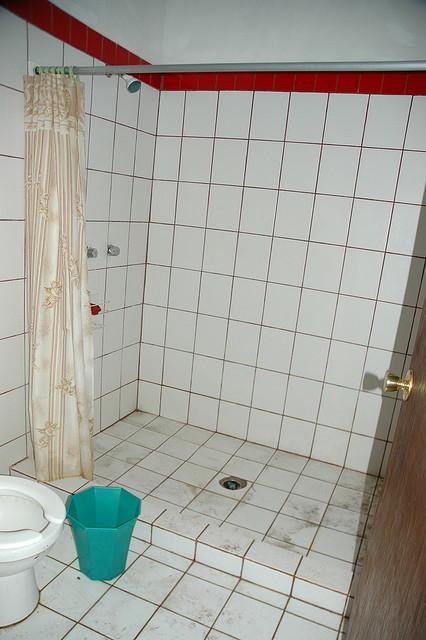How many people are in this photo?
Give a very brief answer. 0. 